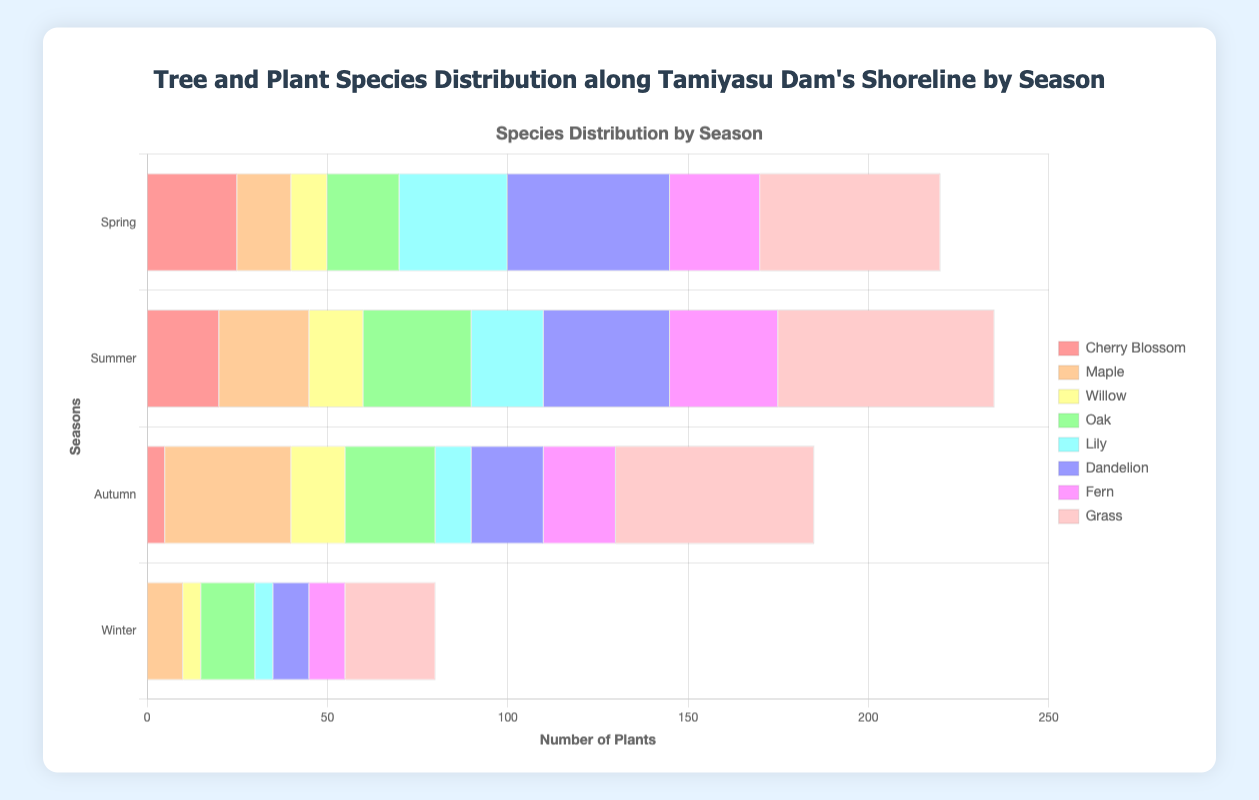Which season has the highest number of Grass plants? By examining the lengths of the bars representing Grass plants in each season, the longest bar corresponds to Summer, indicating the highest count of Grass plants during that season.
Answer: Summer Which Tree Species has the most consistent number across seasons? Cherry Blossom numbers drop significantly in Autumn and Winter, Oak also decreases, and Willow maintains low numbers throughout the seasons. Maple maintains counts that do not decrease as sharply as others, suggesting it's the most consistent.
Answer: Maple What is the total count of Willow in Spring and Summer combined? In Spring, Willow has 10, and in Summer, it has 15. Adding these together gives 10 + 15.
Answer: 25 Which season shows the greatest difference between the number of Dandelion and Lily? In Spring, the difference is 45 - 30 = 15. In Summer, the difference is 35 - 20 = 15. In Autumn, the difference is 20 - 10 = 10. In Winter, the difference is 10 - 5 = 5. Spring and Summer both have the greatest difference of 15.
Answer: Spring and Summer Compare the number of Oak trees in Summer and Autumn. Which season has more? Summer has 30 Oak trees, and Autumn has 25 Oak trees, so Summer has more Oak trees.
Answer: Summer What is the total count of all Plant Species in Winter? In Winter, Lily has 5, Dandelion has 10, Fern has 10, and Grass has 25. Adding these together gives 5 + 10 + 10 + 25.
Answer: 50 Which species shows the most noticeable decline from Spring to Winter? Cherry Blossom starts at 25 in Spring and drops to 0 in Winter, showing the most significant decline.
Answer: Cherry Blossom Which tree species is more prominent in Autumn than in any other season? Maple has the highest count in Autumn (35) compared to Spring (15), Summer (25), and Winter (10).
Answer: Maple What is the sum of the number of Dandelions across all seasons? Spring: 45, Summer: 35, Autumn: 20, Winter: 10. Adding these gives 45 + 35 + 20 + 10.
Answer: 110 